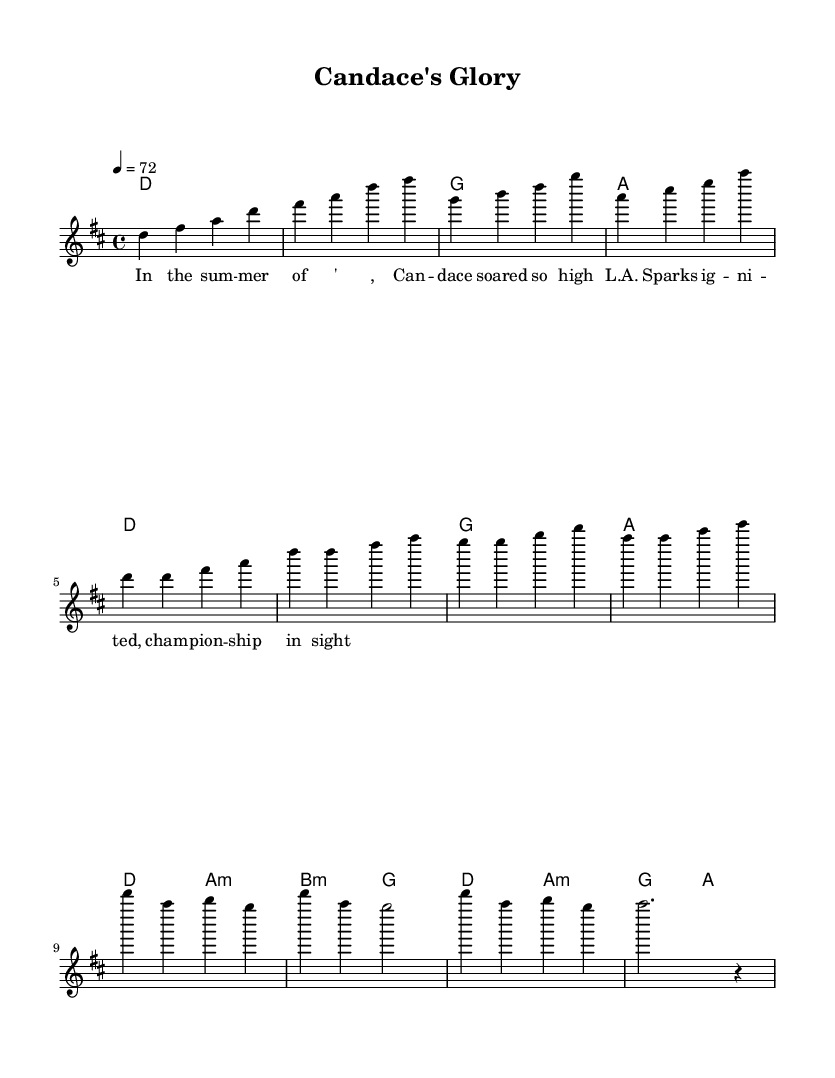What is the key signature of this music? The key signature is D major, which has two sharps. This can be identified in the global section.
Answer: D major What is the time signature of the piece? The time signature is 4/4, indicating that there are four beats per measure. This information is also in the global section as part of the setup.
Answer: 4/4 What is the tempo marking? The tempo marking is 4 equals 72, which suggests a moderate pace. This can be found in the global section where the tempo is specified.
Answer: 72 How many measures are in the chorus? The chorus consists of four measures, as outlined in the melody section where each group of notes corresponds to a measure.
Answer: 4 What chords are found in the first section of the music? The first section includes the chords D, G, and A, which appear in the harmonies section of the score.
Answer: D, G, A What year does the song reference in its lyrics? The song references the summer of '08 in its lyrics, which can be directly read from the verseWords section of the sheet music.
Answer: '08 What is the tonal center for this piece? The tonal center is D, as established by the key signature and emphasized in the melodies and harmonies throughout the score.
Answer: D 